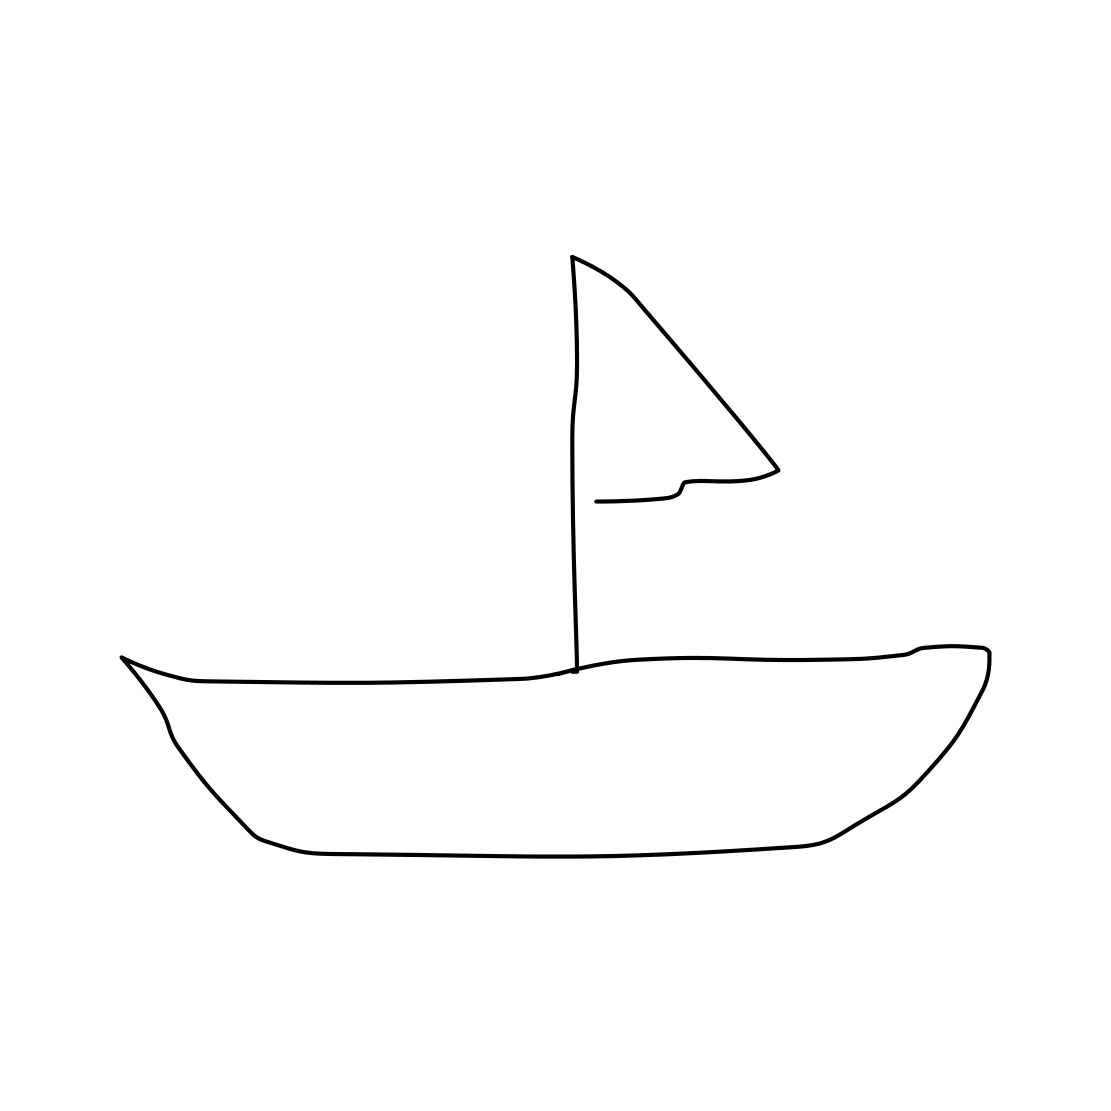What emotions does this image evoke? The simplicity of the line drawing may evoke a sense of tranquility and minimalism. The image of the sailboat alone on a vast blank space can also suggest solitude or freedom. 